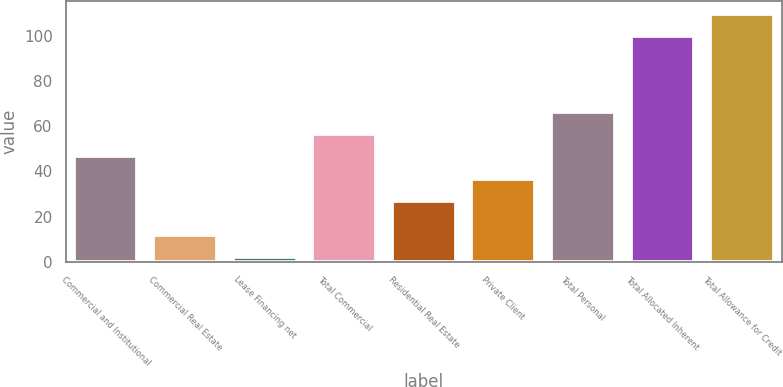<chart> <loc_0><loc_0><loc_500><loc_500><bar_chart><fcel>Commercial and Institutional<fcel>Commercial Real Estate<fcel>Lease Financing net<fcel>Total Commercial<fcel>Residential Real Estate<fcel>Private Client<fcel>Total Personal<fcel>Total Allocated Inherent<fcel>Total Allowance for Credit<nl><fcel>46.6<fcel>12<fcel>2<fcel>56.4<fcel>27<fcel>36.8<fcel>66.2<fcel>100<fcel>109.8<nl></chart> 